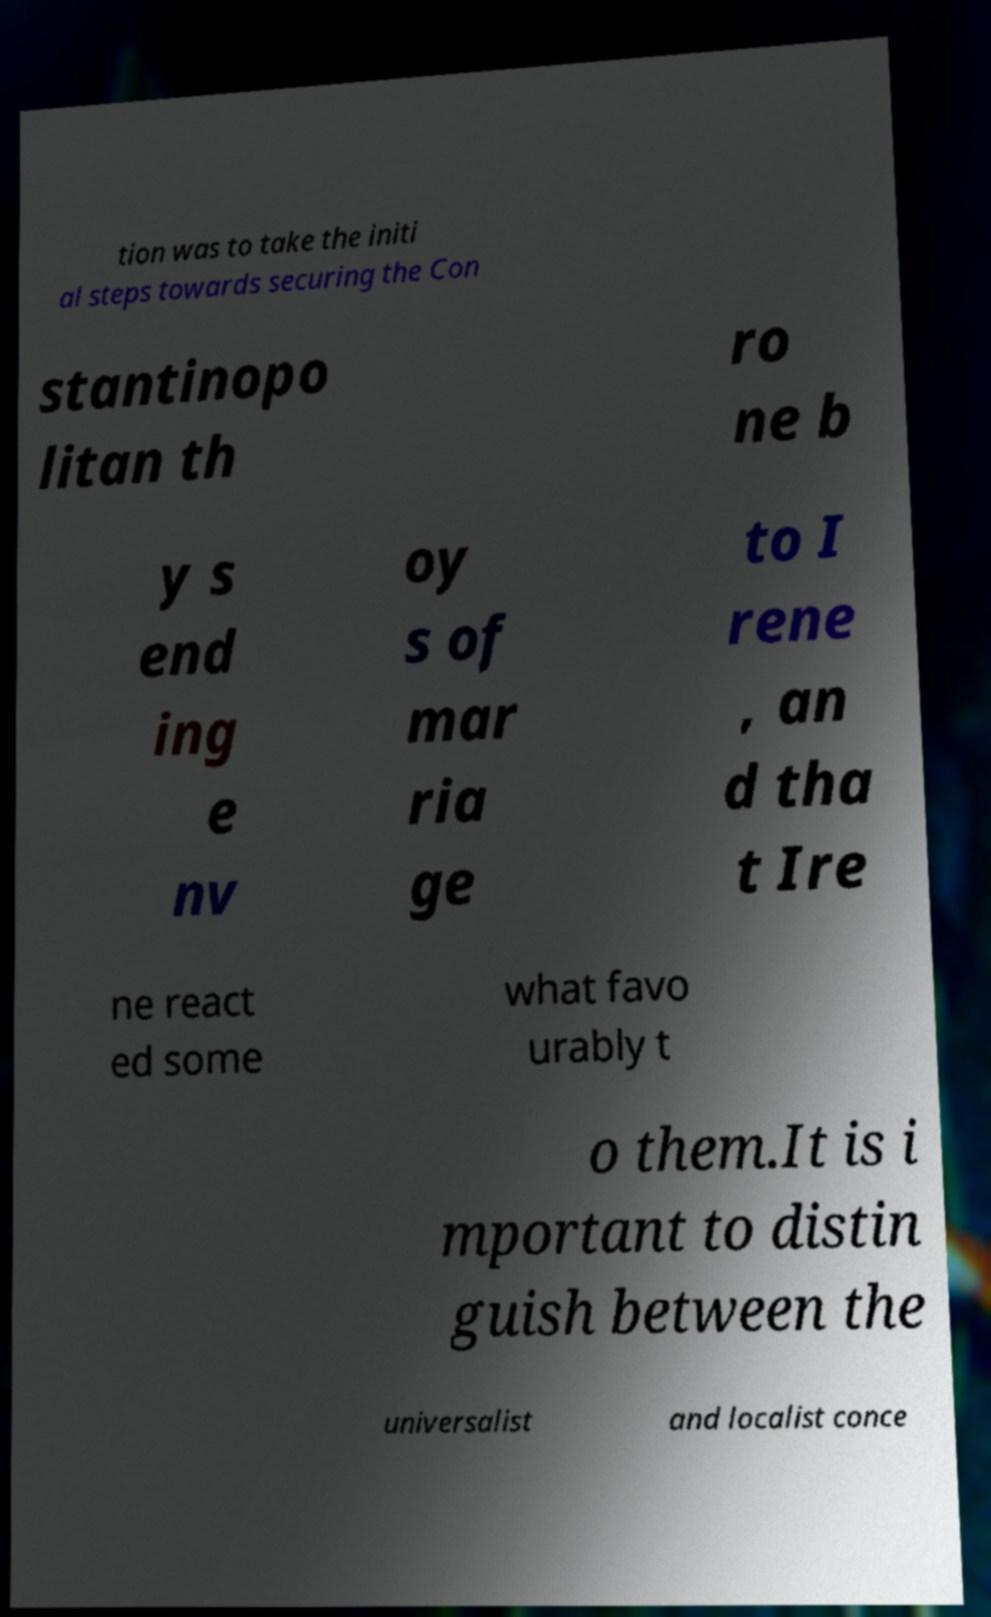There's text embedded in this image that I need extracted. Can you transcribe it verbatim? tion was to take the initi al steps towards securing the Con stantinopo litan th ro ne b y s end ing e nv oy s of mar ria ge to I rene , an d tha t Ire ne react ed some what favo urably t o them.It is i mportant to distin guish between the universalist and localist conce 